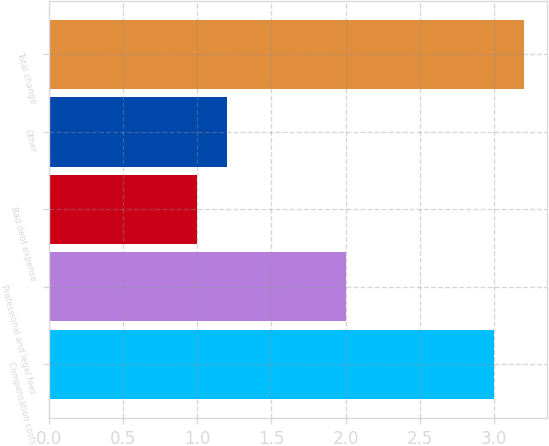<chart> <loc_0><loc_0><loc_500><loc_500><bar_chart><fcel>Compensation costs<fcel>Professional and legal fees<fcel>Bad debt expense<fcel>Other<fcel>Total change<nl><fcel>3<fcel>2<fcel>1<fcel>1.2<fcel>3.2<nl></chart> 